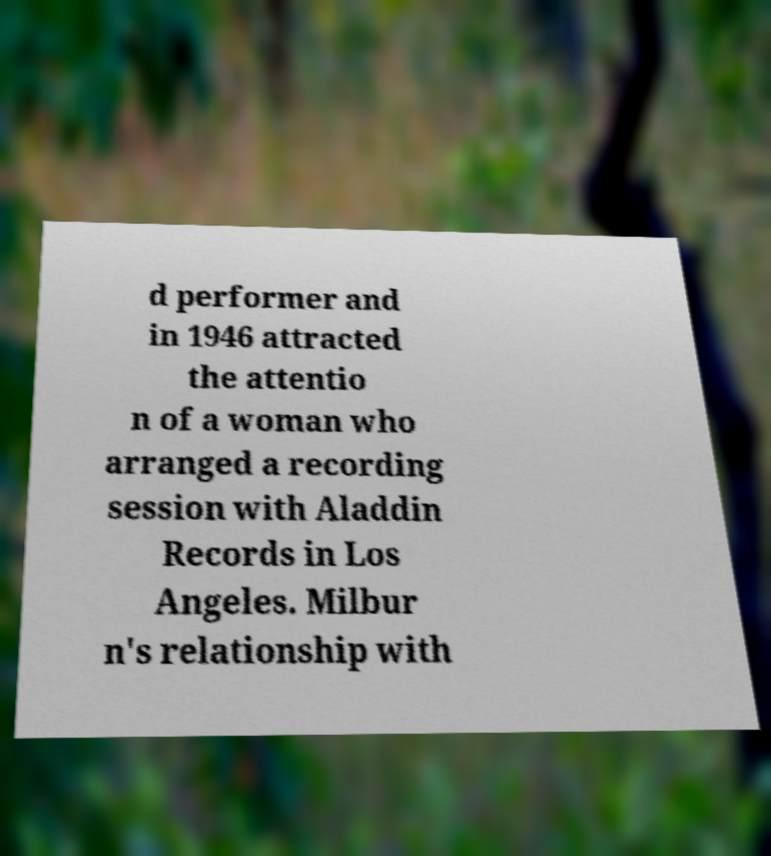Could you assist in decoding the text presented in this image and type it out clearly? d performer and in 1946 attracted the attentio n of a woman who arranged a recording session with Aladdin Records in Los Angeles. Milbur n's relationship with 